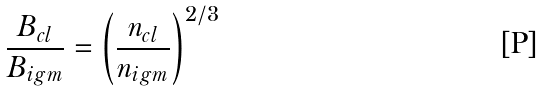Convert formula to latex. <formula><loc_0><loc_0><loc_500><loc_500>\frac { B _ { c l } } { B _ { i g m } } = \left ( \frac { n _ { c l } } { n _ { i g m } } \right ) ^ { 2 / 3 }</formula> 